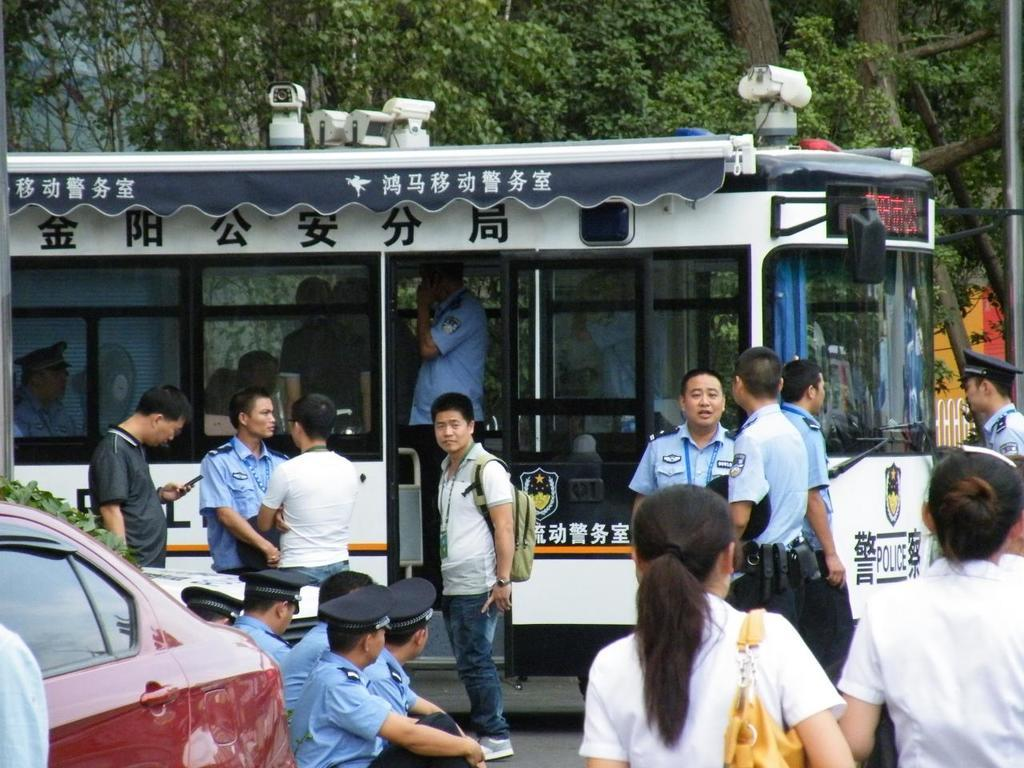Provide a one-sentence caption for the provided image. a bunch of people and police officers  in front of  white bus with Chinese letters all over. 